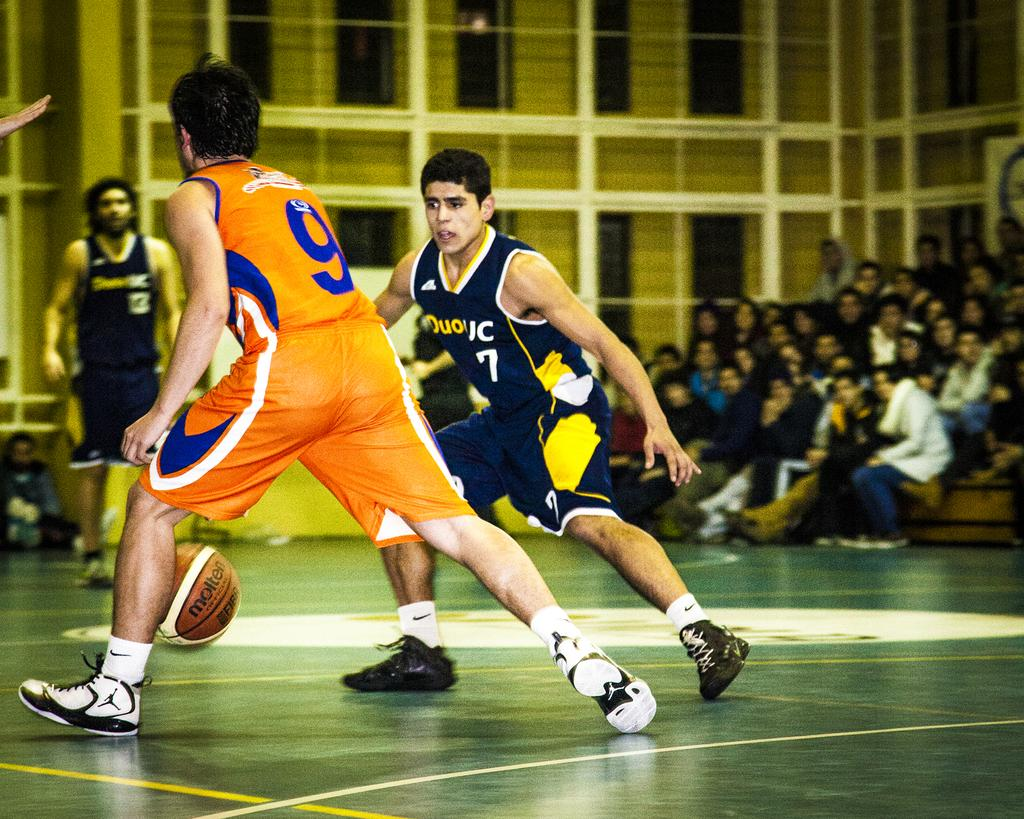<image>
Create a compact narrative representing the image presented. The basketball player with the number 9 on his jersey on has the ball. 